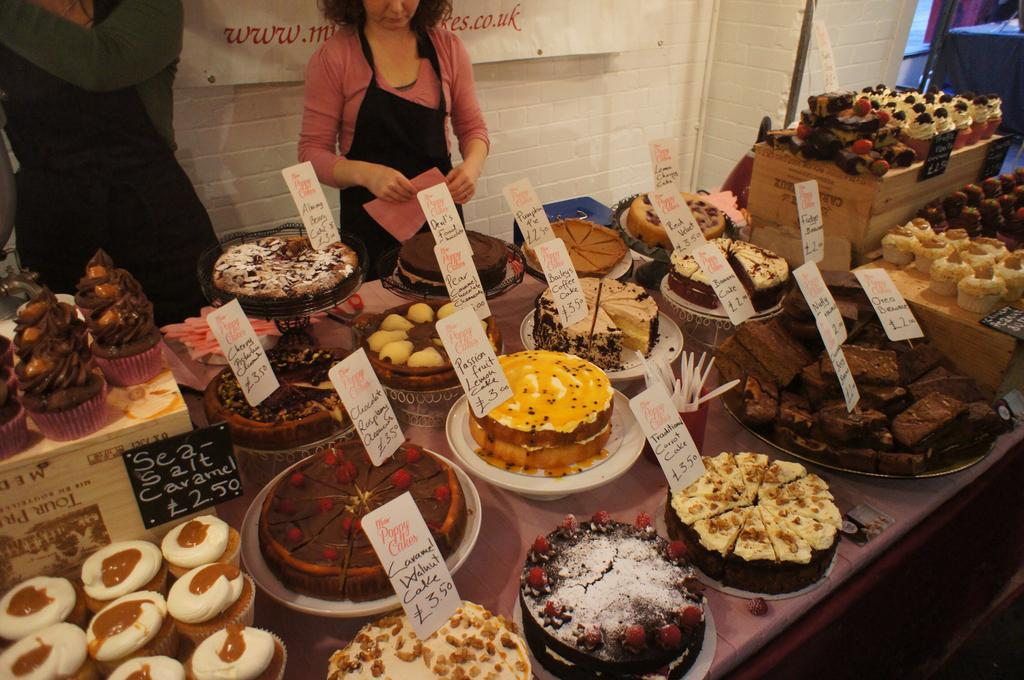What types of foods can be seen in the image? There are different kinds of foods in the image. How are the foods arranged or presented? The foods are placed on serving plates. How can one identify the specific type of food on each plate? There are name boards associated with the foods. What can be seen in the background of the image? In the background of the image, there are persons standing on the floor. What business is being conducted in the image? There is no indication of a business being conducted in the image; it primarily features foods on serving plates with name boards. 